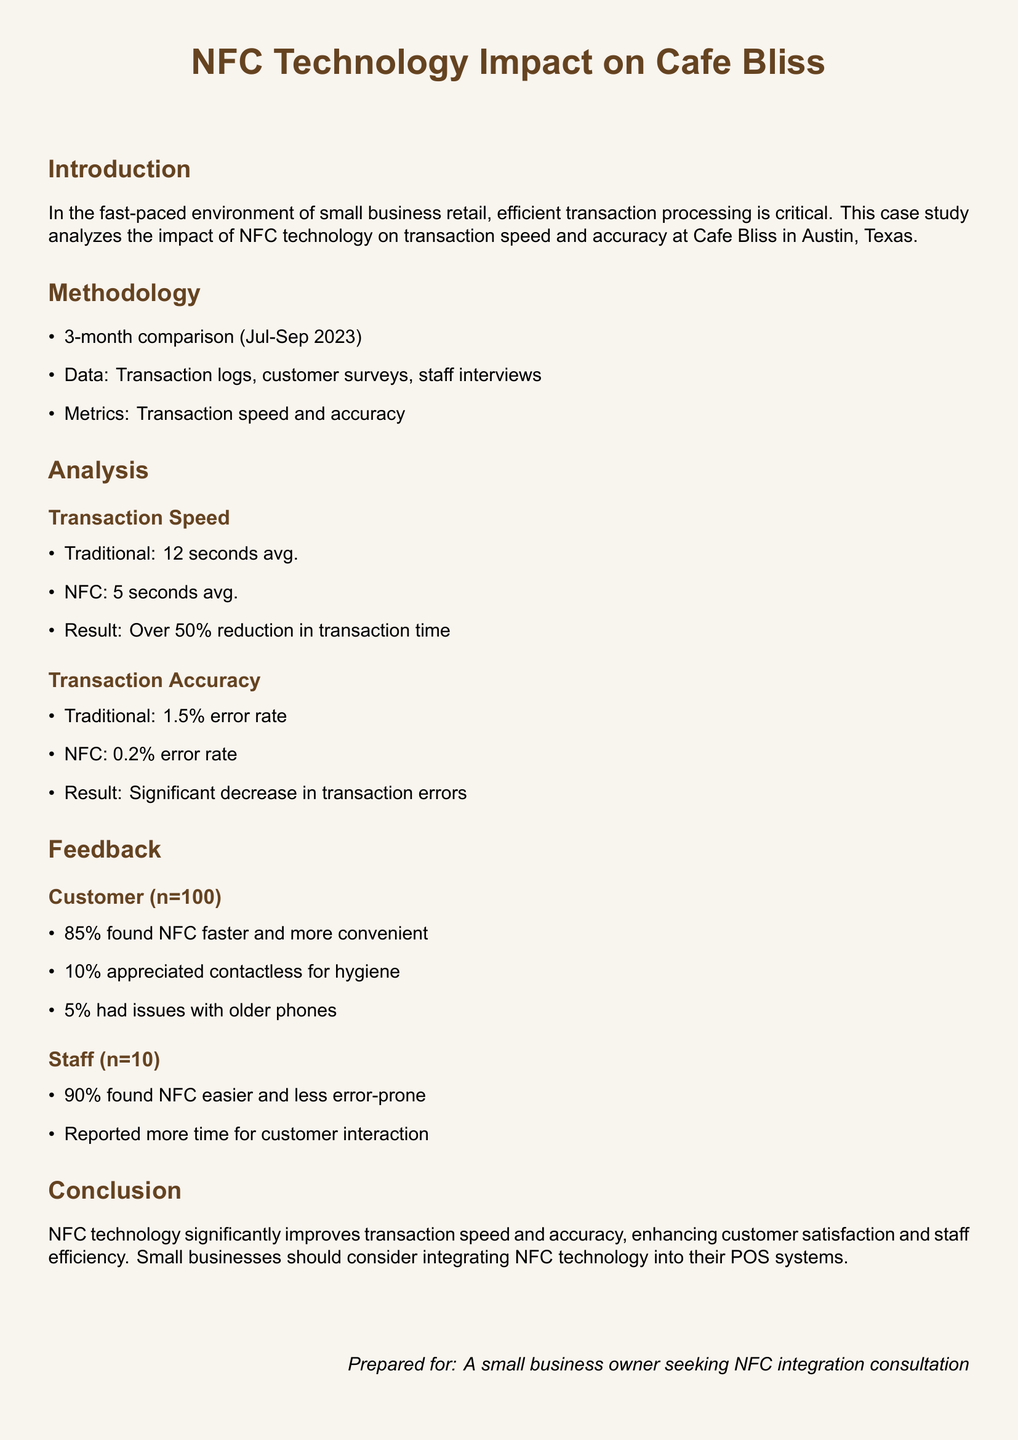What is the duration of the study? The study was conducted over a 3-month period from July to September 2023.
Answer: 3 months What was the average transaction time with traditional card readers? The average transaction time with traditional card readers was noted in the analysis section.
Answer: 12 seconds What was the NFC transaction error rate? The NFC transaction error rate is specified in the analysis of transaction accuracy.
Answer: 0.2% What percentage of customers found NFC faster and more convenient? The percentage of customers who found NFC to be faster and more convenient is included in the feedback section.
Answer: 85% What is the average transaction time with NFC technology? The average transaction time with NFC technology is mentioned in the document.
Answer: 5 seconds What did 90% of staff think about NFC technology? The feedback section reflects staff opinions regarding NFC technology.
Answer: Easier and less error-prone What is the error rate for traditional card readers? The error rate for traditional card readers is indicated in the analysis of transaction accuracy.
Answer: 1.5% What additional benefit did 10% of customers appreciate about NFC? The document mentions a specific benefit appreciated by some customers regarding NFC technology.
Answer: Hygiene What aspect of service improved due to NFC, according to staff? The document describes how staff reported their interactions due to NFC technology.
Answer: Customer interaction 